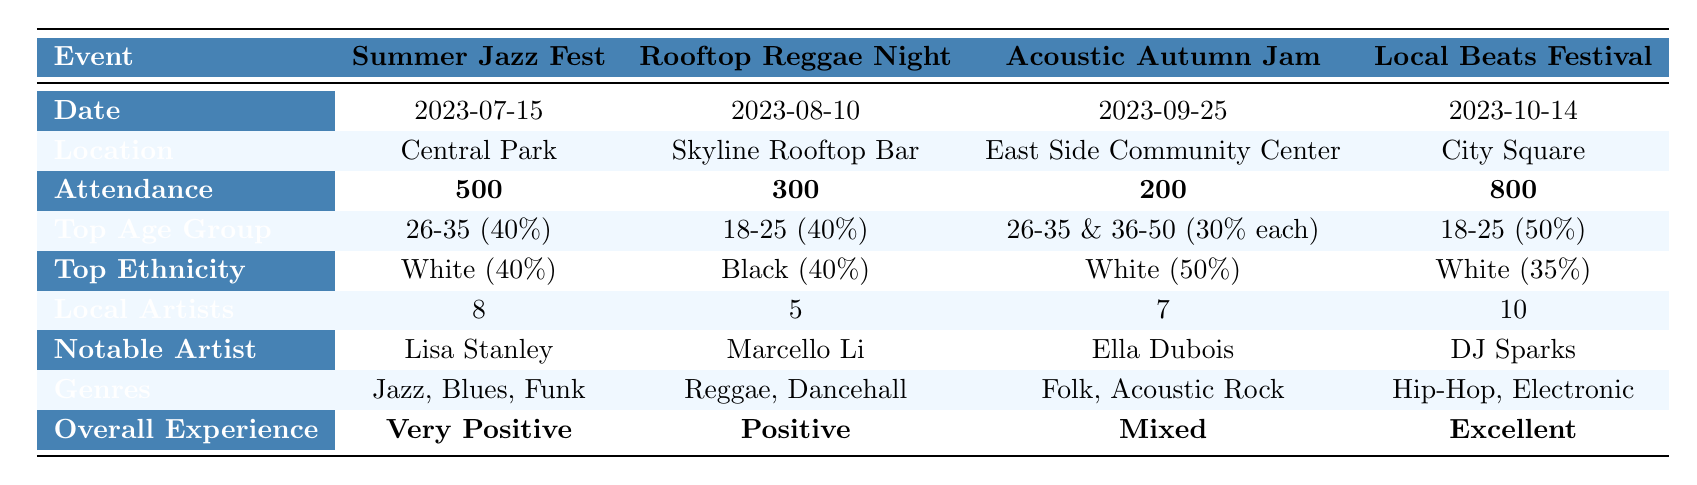What was the location of the Summer Jazz Fest? The table directly lists the location of the Summer Jazz Fest under the "Location" row, which shows "Central Park."
Answer: Central Park How many local artists participated in the Local Beats Festival? The number of local artists for the Local Beats Festival is explicitly stated in the "Local Artists" row, which shows the value of 10.
Answer: 10 What was the overall experience feedback for the Acoustic Autumn Jam? Looking at the "Overall Experience" row, the feedback for the Acoustic Autumn Jam is marked as "Mixed."
Answer: Mixed Which event had the highest attendance? By comparing the attendance figures in the "Attendance" row (500, 300, 200, 800), the Local Beats Festival had the highest attendance at 800.
Answer: Local Beats Festival What percentage of attendees at the Summer Jazz Fest were in the age group 26-35? The "Top Age Group" row indicates that 40% of attendees at the Summer Jazz Fest were in the age group 26-35.
Answer: 40% Is the notable artist for the Rooftop Reggae Night the same as the one for the Summer Jazz Fest? The notable artists listed are Lisa Stanley for the Summer Jazz Fest and Marcello Li for the Rooftop Reggae Night, so they are different people.
Answer: No What is the average attendance across all four events? The total attendance is calculated as 500 + 300 + 200 + 800 = 1800. There are four events, so we calculate the average: 1800 / 4 = 450.
Answer: 450 Which event had the lowest overall experience rating? The overall experience ratings are "Very Positive," "Positive," "Mixed," and "Excellent." "Mixed" is the lowest rating among them, which corresponds to the Acoustic Autumn Jam.
Answer: Acoustic Autumn Jam What is the difference in attendance between the Summer Jazz Fest and the Rooftop Reggae Night? The attendance for the Summer Jazz Fest is 500 and for the Rooftop Reggae Night is 300. The difference is calculated as 500 - 300 = 200.
Answer: 200 Which age demographic had the highest representation at the Local Beats Festival and what was their percentage? Referring to the table, the age demographic 18-25 had the highest representation at 50%.
Answer: 18-25, 50% 